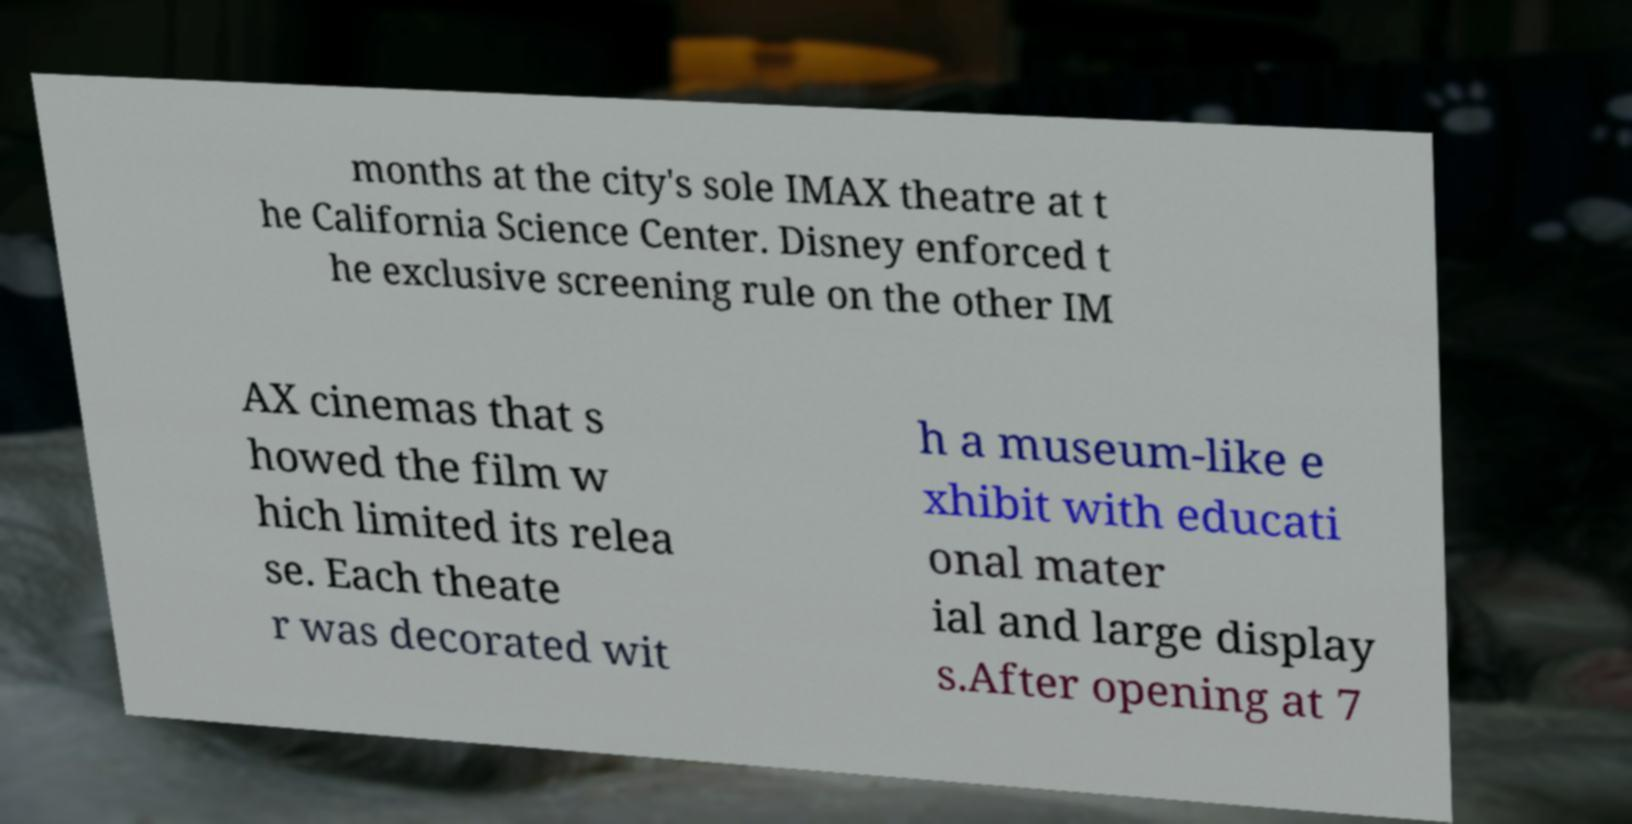Can you accurately transcribe the text from the provided image for me? months at the city's sole IMAX theatre at t he California Science Center. Disney enforced t he exclusive screening rule on the other IM AX cinemas that s howed the film w hich limited its relea se. Each theate r was decorated wit h a museum-like e xhibit with educati onal mater ial and large display s.After opening at 7 